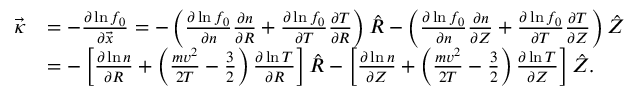<formula> <loc_0><loc_0><loc_500><loc_500>\begin{array} { r l } { \ V e c { \kappa } } & { = - \frac { \partial \ln f _ { 0 } } { \partial \ V e c { x } } = - \left ( \frac { \partial \ln f _ { 0 } } { \partial n } \frac { \partial n } { \partial R } + \frac { \partial \ln f _ { 0 } } { \partial T } \frac { \partial T } { \partial R } \right ) \hat { R } - \left ( \frac { \partial \ln f _ { 0 } } { \partial n } \frac { \partial n } { \partial Z } + \frac { \partial \ln f _ { 0 } } { \partial T } \frac { \partial T } { \partial Z } \right ) \hat { Z } } \\ & { = - \left [ \frac { \partial \ln n } { \partial R } + \left ( \frac { m v ^ { 2 } } { 2 T } - \frac { 3 } { 2 } \right ) \frac { \partial \ln T } { \partial R } \right ] \hat { R } - \left [ \frac { \partial \ln n } { \partial Z } + \left ( \frac { m v ^ { 2 } } { 2 T } - \frac { 3 } { 2 } \right ) \frac { \partial \ln T } { \partial Z } \right ] \hat { Z } . } \end{array}</formula> 